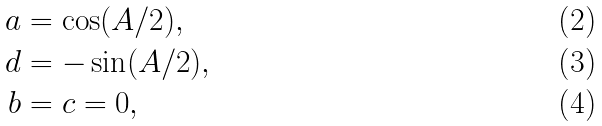<formula> <loc_0><loc_0><loc_500><loc_500>a & = \cos ( A / 2 ) , \\ d & = - \sin ( A / 2 ) , \\ b & = c = 0 ,</formula> 